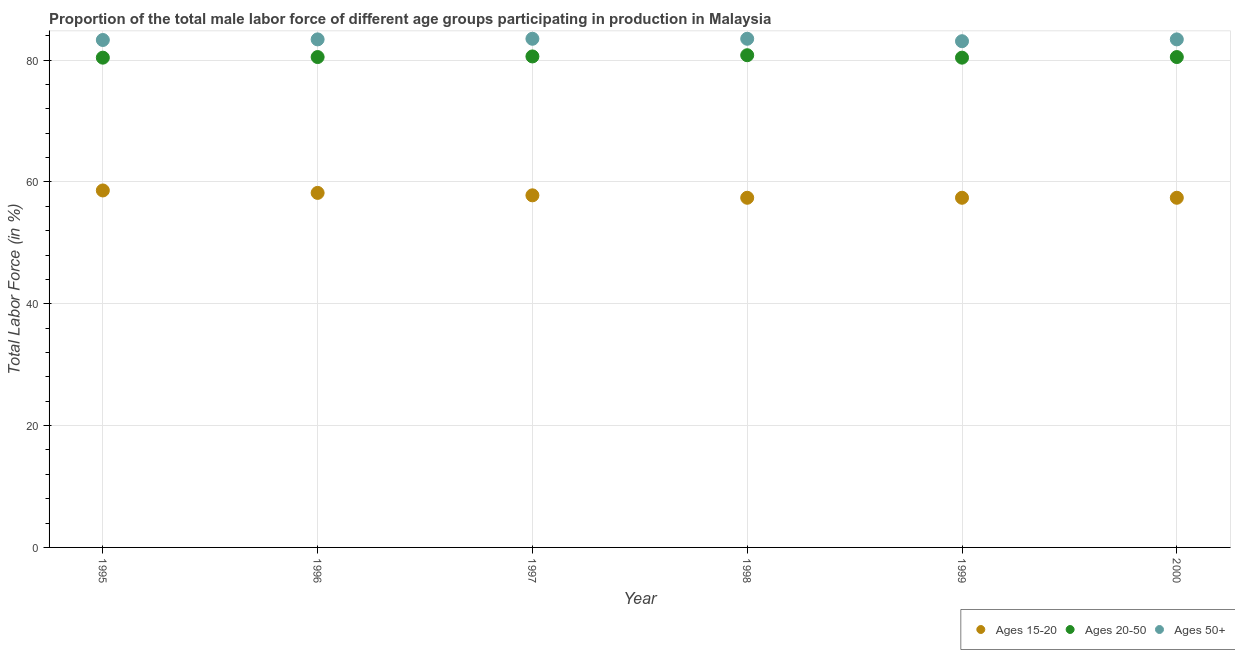What is the percentage of male labor force within the age group 15-20 in 1996?
Offer a very short reply. 58.2. Across all years, what is the maximum percentage of male labor force within the age group 20-50?
Your response must be concise. 80.8. Across all years, what is the minimum percentage of male labor force within the age group 15-20?
Your answer should be compact. 57.4. In which year was the percentage of male labor force within the age group 15-20 minimum?
Provide a succinct answer. 1998. What is the total percentage of male labor force above age 50 in the graph?
Your answer should be very brief. 500.2. What is the difference between the percentage of male labor force above age 50 in 1996 and that in 1997?
Offer a very short reply. -0.1. What is the difference between the percentage of male labor force within the age group 15-20 in 1997 and the percentage of male labor force within the age group 20-50 in 1996?
Your answer should be very brief. -22.7. What is the average percentage of male labor force within the age group 15-20 per year?
Ensure brevity in your answer.  57.8. In the year 1999, what is the difference between the percentage of male labor force within the age group 20-50 and percentage of male labor force within the age group 15-20?
Make the answer very short. 23. What is the ratio of the percentage of male labor force above age 50 in 1995 to that in 1996?
Your answer should be very brief. 1. Is the difference between the percentage of male labor force within the age group 15-20 in 1996 and 2000 greater than the difference between the percentage of male labor force above age 50 in 1996 and 2000?
Offer a very short reply. Yes. What is the difference between the highest and the second highest percentage of male labor force within the age group 20-50?
Offer a terse response. 0.2. What is the difference between the highest and the lowest percentage of male labor force above age 50?
Offer a terse response. 0.4. Is the sum of the percentage of male labor force within the age group 15-20 in 1996 and 1998 greater than the maximum percentage of male labor force above age 50 across all years?
Provide a short and direct response. Yes. Does the percentage of male labor force within the age group 15-20 monotonically increase over the years?
Ensure brevity in your answer.  No. Is the percentage of male labor force above age 50 strictly less than the percentage of male labor force within the age group 15-20 over the years?
Your answer should be compact. No. How many years are there in the graph?
Your response must be concise. 6. What is the difference between two consecutive major ticks on the Y-axis?
Provide a short and direct response. 20. Are the values on the major ticks of Y-axis written in scientific E-notation?
Give a very brief answer. No. Does the graph contain any zero values?
Provide a short and direct response. No. What is the title of the graph?
Make the answer very short. Proportion of the total male labor force of different age groups participating in production in Malaysia. Does "Services" appear as one of the legend labels in the graph?
Your answer should be compact. No. What is the label or title of the Y-axis?
Make the answer very short. Total Labor Force (in %). What is the Total Labor Force (in %) of Ages 15-20 in 1995?
Keep it short and to the point. 58.6. What is the Total Labor Force (in %) in Ages 20-50 in 1995?
Ensure brevity in your answer.  80.4. What is the Total Labor Force (in %) in Ages 50+ in 1995?
Your answer should be very brief. 83.3. What is the Total Labor Force (in %) in Ages 15-20 in 1996?
Offer a terse response. 58.2. What is the Total Labor Force (in %) in Ages 20-50 in 1996?
Your response must be concise. 80.5. What is the Total Labor Force (in %) in Ages 50+ in 1996?
Provide a short and direct response. 83.4. What is the Total Labor Force (in %) of Ages 15-20 in 1997?
Ensure brevity in your answer.  57.8. What is the Total Labor Force (in %) in Ages 20-50 in 1997?
Make the answer very short. 80.6. What is the Total Labor Force (in %) in Ages 50+ in 1997?
Your response must be concise. 83.5. What is the Total Labor Force (in %) of Ages 15-20 in 1998?
Provide a short and direct response. 57.4. What is the Total Labor Force (in %) of Ages 20-50 in 1998?
Provide a short and direct response. 80.8. What is the Total Labor Force (in %) of Ages 50+ in 1998?
Your answer should be compact. 83.5. What is the Total Labor Force (in %) in Ages 15-20 in 1999?
Provide a succinct answer. 57.4. What is the Total Labor Force (in %) in Ages 20-50 in 1999?
Your response must be concise. 80.4. What is the Total Labor Force (in %) in Ages 50+ in 1999?
Provide a succinct answer. 83.1. What is the Total Labor Force (in %) in Ages 15-20 in 2000?
Your answer should be very brief. 57.4. What is the Total Labor Force (in %) of Ages 20-50 in 2000?
Your answer should be compact. 80.5. What is the Total Labor Force (in %) in Ages 50+ in 2000?
Offer a very short reply. 83.4. Across all years, what is the maximum Total Labor Force (in %) in Ages 15-20?
Offer a terse response. 58.6. Across all years, what is the maximum Total Labor Force (in %) in Ages 20-50?
Ensure brevity in your answer.  80.8. Across all years, what is the maximum Total Labor Force (in %) of Ages 50+?
Keep it short and to the point. 83.5. Across all years, what is the minimum Total Labor Force (in %) of Ages 15-20?
Give a very brief answer. 57.4. Across all years, what is the minimum Total Labor Force (in %) of Ages 20-50?
Offer a terse response. 80.4. Across all years, what is the minimum Total Labor Force (in %) in Ages 50+?
Your response must be concise. 83.1. What is the total Total Labor Force (in %) of Ages 15-20 in the graph?
Offer a terse response. 346.8. What is the total Total Labor Force (in %) of Ages 20-50 in the graph?
Ensure brevity in your answer.  483.2. What is the total Total Labor Force (in %) of Ages 50+ in the graph?
Your answer should be very brief. 500.2. What is the difference between the Total Labor Force (in %) of Ages 15-20 in 1995 and that in 1996?
Make the answer very short. 0.4. What is the difference between the Total Labor Force (in %) in Ages 20-50 in 1995 and that in 1996?
Your answer should be compact. -0.1. What is the difference between the Total Labor Force (in %) of Ages 50+ in 1995 and that in 1996?
Your answer should be compact. -0.1. What is the difference between the Total Labor Force (in %) in Ages 15-20 in 1995 and that in 1997?
Provide a short and direct response. 0.8. What is the difference between the Total Labor Force (in %) in Ages 20-50 in 1995 and that in 1997?
Make the answer very short. -0.2. What is the difference between the Total Labor Force (in %) of Ages 15-20 in 1995 and that in 1998?
Keep it short and to the point. 1.2. What is the difference between the Total Labor Force (in %) in Ages 20-50 in 1995 and that in 1998?
Your answer should be very brief. -0.4. What is the difference between the Total Labor Force (in %) of Ages 50+ in 1995 and that in 1998?
Offer a very short reply. -0.2. What is the difference between the Total Labor Force (in %) of Ages 15-20 in 1995 and that in 1999?
Provide a succinct answer. 1.2. What is the difference between the Total Labor Force (in %) in Ages 50+ in 1995 and that in 1999?
Offer a very short reply. 0.2. What is the difference between the Total Labor Force (in %) of Ages 15-20 in 1995 and that in 2000?
Keep it short and to the point. 1.2. What is the difference between the Total Labor Force (in %) in Ages 20-50 in 1995 and that in 2000?
Provide a succinct answer. -0.1. What is the difference between the Total Labor Force (in %) in Ages 50+ in 1995 and that in 2000?
Your answer should be very brief. -0.1. What is the difference between the Total Labor Force (in %) of Ages 20-50 in 1996 and that in 1997?
Your answer should be compact. -0.1. What is the difference between the Total Labor Force (in %) in Ages 15-20 in 1996 and that in 1998?
Make the answer very short. 0.8. What is the difference between the Total Labor Force (in %) in Ages 50+ in 1996 and that in 1998?
Provide a short and direct response. -0.1. What is the difference between the Total Labor Force (in %) in Ages 50+ in 1996 and that in 1999?
Provide a short and direct response. 0.3. What is the difference between the Total Labor Force (in %) of Ages 15-20 in 1996 and that in 2000?
Make the answer very short. 0.8. What is the difference between the Total Labor Force (in %) in Ages 50+ in 1996 and that in 2000?
Your answer should be compact. 0. What is the difference between the Total Labor Force (in %) in Ages 15-20 in 1997 and that in 1998?
Your answer should be very brief. 0.4. What is the difference between the Total Labor Force (in %) in Ages 20-50 in 1997 and that in 1998?
Your answer should be very brief. -0.2. What is the difference between the Total Labor Force (in %) in Ages 50+ in 1997 and that in 1998?
Offer a very short reply. 0. What is the difference between the Total Labor Force (in %) of Ages 50+ in 1997 and that in 1999?
Ensure brevity in your answer.  0.4. What is the difference between the Total Labor Force (in %) in Ages 15-20 in 1997 and that in 2000?
Offer a terse response. 0.4. What is the difference between the Total Labor Force (in %) of Ages 50+ in 1997 and that in 2000?
Give a very brief answer. 0.1. What is the difference between the Total Labor Force (in %) in Ages 20-50 in 1998 and that in 2000?
Your answer should be very brief. 0.3. What is the difference between the Total Labor Force (in %) in Ages 50+ in 1998 and that in 2000?
Give a very brief answer. 0.1. What is the difference between the Total Labor Force (in %) in Ages 15-20 in 1999 and that in 2000?
Your answer should be compact. 0. What is the difference between the Total Labor Force (in %) in Ages 20-50 in 1999 and that in 2000?
Offer a terse response. -0.1. What is the difference between the Total Labor Force (in %) in Ages 50+ in 1999 and that in 2000?
Give a very brief answer. -0.3. What is the difference between the Total Labor Force (in %) in Ages 15-20 in 1995 and the Total Labor Force (in %) in Ages 20-50 in 1996?
Offer a very short reply. -21.9. What is the difference between the Total Labor Force (in %) in Ages 15-20 in 1995 and the Total Labor Force (in %) in Ages 50+ in 1996?
Keep it short and to the point. -24.8. What is the difference between the Total Labor Force (in %) of Ages 15-20 in 1995 and the Total Labor Force (in %) of Ages 20-50 in 1997?
Your answer should be compact. -22. What is the difference between the Total Labor Force (in %) of Ages 15-20 in 1995 and the Total Labor Force (in %) of Ages 50+ in 1997?
Offer a very short reply. -24.9. What is the difference between the Total Labor Force (in %) of Ages 15-20 in 1995 and the Total Labor Force (in %) of Ages 20-50 in 1998?
Make the answer very short. -22.2. What is the difference between the Total Labor Force (in %) in Ages 15-20 in 1995 and the Total Labor Force (in %) in Ages 50+ in 1998?
Your answer should be compact. -24.9. What is the difference between the Total Labor Force (in %) of Ages 20-50 in 1995 and the Total Labor Force (in %) of Ages 50+ in 1998?
Your answer should be compact. -3.1. What is the difference between the Total Labor Force (in %) in Ages 15-20 in 1995 and the Total Labor Force (in %) in Ages 20-50 in 1999?
Make the answer very short. -21.8. What is the difference between the Total Labor Force (in %) in Ages 15-20 in 1995 and the Total Labor Force (in %) in Ages 50+ in 1999?
Make the answer very short. -24.5. What is the difference between the Total Labor Force (in %) in Ages 15-20 in 1995 and the Total Labor Force (in %) in Ages 20-50 in 2000?
Make the answer very short. -21.9. What is the difference between the Total Labor Force (in %) of Ages 15-20 in 1995 and the Total Labor Force (in %) of Ages 50+ in 2000?
Make the answer very short. -24.8. What is the difference between the Total Labor Force (in %) in Ages 20-50 in 1995 and the Total Labor Force (in %) in Ages 50+ in 2000?
Your response must be concise. -3. What is the difference between the Total Labor Force (in %) of Ages 15-20 in 1996 and the Total Labor Force (in %) of Ages 20-50 in 1997?
Offer a terse response. -22.4. What is the difference between the Total Labor Force (in %) of Ages 15-20 in 1996 and the Total Labor Force (in %) of Ages 50+ in 1997?
Make the answer very short. -25.3. What is the difference between the Total Labor Force (in %) of Ages 20-50 in 1996 and the Total Labor Force (in %) of Ages 50+ in 1997?
Offer a terse response. -3. What is the difference between the Total Labor Force (in %) of Ages 15-20 in 1996 and the Total Labor Force (in %) of Ages 20-50 in 1998?
Your response must be concise. -22.6. What is the difference between the Total Labor Force (in %) in Ages 15-20 in 1996 and the Total Labor Force (in %) in Ages 50+ in 1998?
Give a very brief answer. -25.3. What is the difference between the Total Labor Force (in %) in Ages 20-50 in 1996 and the Total Labor Force (in %) in Ages 50+ in 1998?
Your answer should be compact. -3. What is the difference between the Total Labor Force (in %) of Ages 15-20 in 1996 and the Total Labor Force (in %) of Ages 20-50 in 1999?
Offer a terse response. -22.2. What is the difference between the Total Labor Force (in %) of Ages 15-20 in 1996 and the Total Labor Force (in %) of Ages 50+ in 1999?
Your answer should be very brief. -24.9. What is the difference between the Total Labor Force (in %) of Ages 15-20 in 1996 and the Total Labor Force (in %) of Ages 20-50 in 2000?
Keep it short and to the point. -22.3. What is the difference between the Total Labor Force (in %) of Ages 15-20 in 1996 and the Total Labor Force (in %) of Ages 50+ in 2000?
Offer a terse response. -25.2. What is the difference between the Total Labor Force (in %) in Ages 15-20 in 1997 and the Total Labor Force (in %) in Ages 50+ in 1998?
Make the answer very short. -25.7. What is the difference between the Total Labor Force (in %) in Ages 15-20 in 1997 and the Total Labor Force (in %) in Ages 20-50 in 1999?
Provide a succinct answer. -22.6. What is the difference between the Total Labor Force (in %) in Ages 15-20 in 1997 and the Total Labor Force (in %) in Ages 50+ in 1999?
Keep it short and to the point. -25.3. What is the difference between the Total Labor Force (in %) of Ages 15-20 in 1997 and the Total Labor Force (in %) of Ages 20-50 in 2000?
Make the answer very short. -22.7. What is the difference between the Total Labor Force (in %) of Ages 15-20 in 1997 and the Total Labor Force (in %) of Ages 50+ in 2000?
Give a very brief answer. -25.6. What is the difference between the Total Labor Force (in %) in Ages 15-20 in 1998 and the Total Labor Force (in %) in Ages 50+ in 1999?
Ensure brevity in your answer.  -25.7. What is the difference between the Total Labor Force (in %) of Ages 20-50 in 1998 and the Total Labor Force (in %) of Ages 50+ in 1999?
Ensure brevity in your answer.  -2.3. What is the difference between the Total Labor Force (in %) in Ages 15-20 in 1998 and the Total Labor Force (in %) in Ages 20-50 in 2000?
Ensure brevity in your answer.  -23.1. What is the difference between the Total Labor Force (in %) in Ages 20-50 in 1998 and the Total Labor Force (in %) in Ages 50+ in 2000?
Give a very brief answer. -2.6. What is the difference between the Total Labor Force (in %) in Ages 15-20 in 1999 and the Total Labor Force (in %) in Ages 20-50 in 2000?
Ensure brevity in your answer.  -23.1. What is the average Total Labor Force (in %) in Ages 15-20 per year?
Provide a short and direct response. 57.8. What is the average Total Labor Force (in %) of Ages 20-50 per year?
Make the answer very short. 80.53. What is the average Total Labor Force (in %) in Ages 50+ per year?
Your response must be concise. 83.37. In the year 1995, what is the difference between the Total Labor Force (in %) of Ages 15-20 and Total Labor Force (in %) of Ages 20-50?
Keep it short and to the point. -21.8. In the year 1995, what is the difference between the Total Labor Force (in %) in Ages 15-20 and Total Labor Force (in %) in Ages 50+?
Offer a very short reply. -24.7. In the year 1996, what is the difference between the Total Labor Force (in %) in Ages 15-20 and Total Labor Force (in %) in Ages 20-50?
Give a very brief answer. -22.3. In the year 1996, what is the difference between the Total Labor Force (in %) of Ages 15-20 and Total Labor Force (in %) of Ages 50+?
Offer a very short reply. -25.2. In the year 1997, what is the difference between the Total Labor Force (in %) in Ages 15-20 and Total Labor Force (in %) in Ages 20-50?
Your answer should be compact. -22.8. In the year 1997, what is the difference between the Total Labor Force (in %) in Ages 15-20 and Total Labor Force (in %) in Ages 50+?
Your answer should be very brief. -25.7. In the year 1997, what is the difference between the Total Labor Force (in %) of Ages 20-50 and Total Labor Force (in %) of Ages 50+?
Give a very brief answer. -2.9. In the year 1998, what is the difference between the Total Labor Force (in %) in Ages 15-20 and Total Labor Force (in %) in Ages 20-50?
Your answer should be very brief. -23.4. In the year 1998, what is the difference between the Total Labor Force (in %) in Ages 15-20 and Total Labor Force (in %) in Ages 50+?
Your response must be concise. -26.1. In the year 1999, what is the difference between the Total Labor Force (in %) of Ages 15-20 and Total Labor Force (in %) of Ages 20-50?
Your answer should be compact. -23. In the year 1999, what is the difference between the Total Labor Force (in %) in Ages 15-20 and Total Labor Force (in %) in Ages 50+?
Provide a succinct answer. -25.7. In the year 2000, what is the difference between the Total Labor Force (in %) in Ages 15-20 and Total Labor Force (in %) in Ages 20-50?
Ensure brevity in your answer.  -23.1. In the year 2000, what is the difference between the Total Labor Force (in %) in Ages 15-20 and Total Labor Force (in %) in Ages 50+?
Your answer should be compact. -26. What is the ratio of the Total Labor Force (in %) of Ages 15-20 in 1995 to that in 1996?
Your answer should be compact. 1.01. What is the ratio of the Total Labor Force (in %) in Ages 15-20 in 1995 to that in 1997?
Ensure brevity in your answer.  1.01. What is the ratio of the Total Labor Force (in %) of Ages 20-50 in 1995 to that in 1997?
Ensure brevity in your answer.  1. What is the ratio of the Total Labor Force (in %) in Ages 50+ in 1995 to that in 1997?
Make the answer very short. 1. What is the ratio of the Total Labor Force (in %) of Ages 15-20 in 1995 to that in 1998?
Give a very brief answer. 1.02. What is the ratio of the Total Labor Force (in %) of Ages 15-20 in 1995 to that in 1999?
Offer a very short reply. 1.02. What is the ratio of the Total Labor Force (in %) of Ages 15-20 in 1995 to that in 2000?
Your response must be concise. 1.02. What is the ratio of the Total Labor Force (in %) of Ages 20-50 in 1996 to that in 1997?
Ensure brevity in your answer.  1. What is the ratio of the Total Labor Force (in %) in Ages 15-20 in 1996 to that in 1998?
Your answer should be compact. 1.01. What is the ratio of the Total Labor Force (in %) in Ages 15-20 in 1996 to that in 1999?
Offer a very short reply. 1.01. What is the ratio of the Total Labor Force (in %) of Ages 50+ in 1996 to that in 1999?
Give a very brief answer. 1. What is the ratio of the Total Labor Force (in %) in Ages 15-20 in 1996 to that in 2000?
Your answer should be very brief. 1.01. What is the ratio of the Total Labor Force (in %) in Ages 20-50 in 1996 to that in 2000?
Your answer should be compact. 1. What is the ratio of the Total Labor Force (in %) of Ages 20-50 in 1997 to that in 1998?
Offer a very short reply. 1. What is the ratio of the Total Labor Force (in %) of Ages 50+ in 1997 to that in 1999?
Your response must be concise. 1. What is the ratio of the Total Labor Force (in %) of Ages 15-20 in 1997 to that in 2000?
Give a very brief answer. 1.01. What is the ratio of the Total Labor Force (in %) in Ages 20-50 in 1997 to that in 2000?
Ensure brevity in your answer.  1. What is the ratio of the Total Labor Force (in %) of Ages 15-20 in 1998 to that in 1999?
Provide a short and direct response. 1. What is the ratio of the Total Labor Force (in %) in Ages 20-50 in 1998 to that in 1999?
Offer a terse response. 1. What is the ratio of the Total Labor Force (in %) of Ages 50+ in 1998 to that in 2000?
Give a very brief answer. 1. What is the ratio of the Total Labor Force (in %) of Ages 15-20 in 1999 to that in 2000?
Your answer should be compact. 1. What is the ratio of the Total Labor Force (in %) of Ages 20-50 in 1999 to that in 2000?
Make the answer very short. 1. What is the difference between the highest and the second highest Total Labor Force (in %) in Ages 15-20?
Make the answer very short. 0.4. What is the difference between the highest and the second highest Total Labor Force (in %) in Ages 20-50?
Make the answer very short. 0.2. What is the difference between the highest and the second highest Total Labor Force (in %) of Ages 50+?
Your answer should be compact. 0. What is the difference between the highest and the lowest Total Labor Force (in %) in Ages 15-20?
Provide a succinct answer. 1.2. What is the difference between the highest and the lowest Total Labor Force (in %) of Ages 20-50?
Make the answer very short. 0.4. 